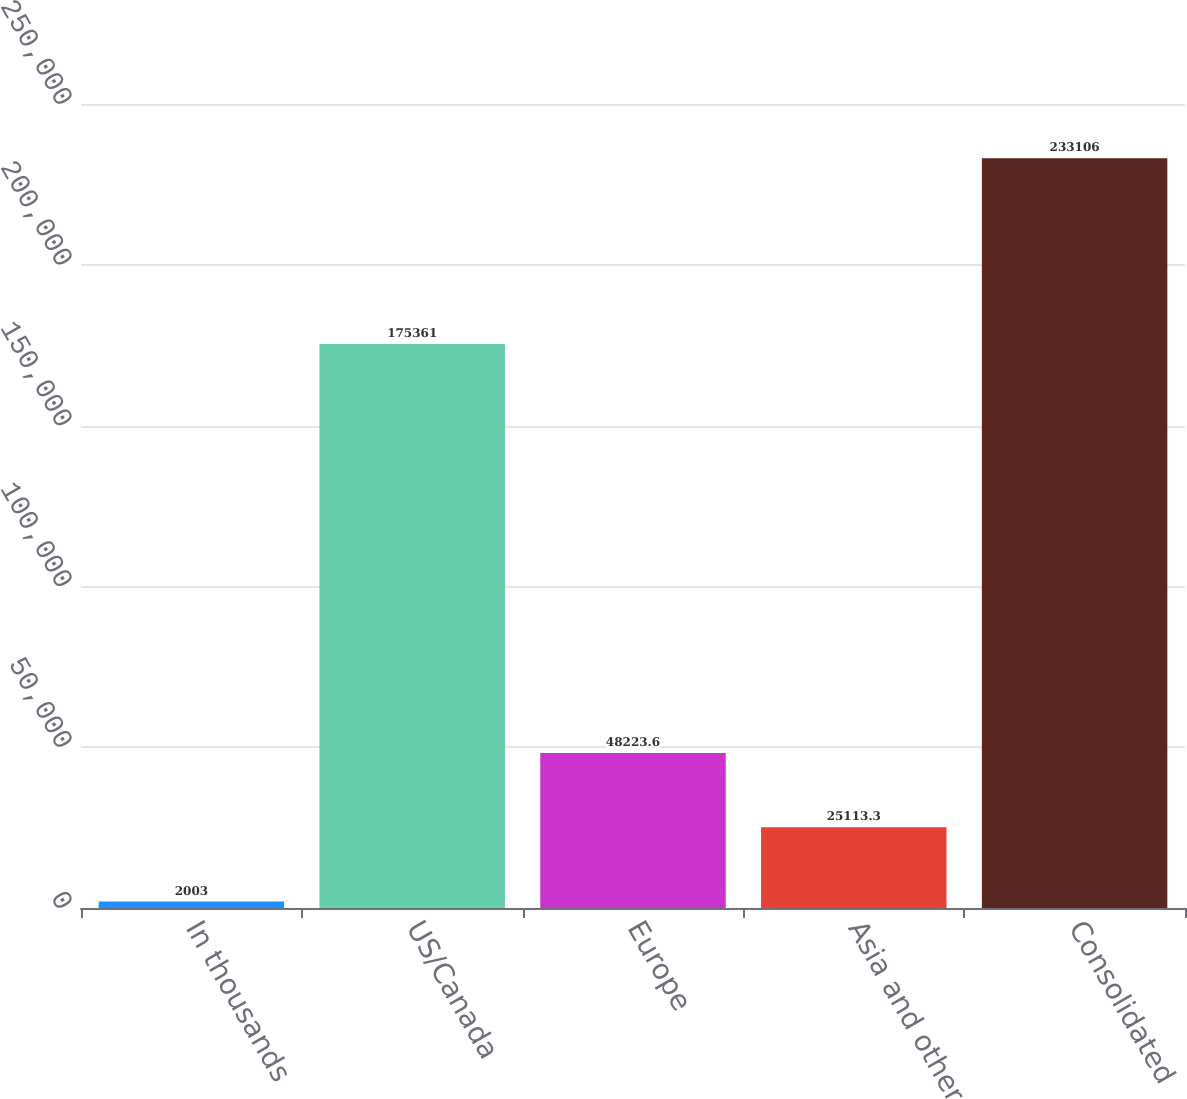Convert chart to OTSL. <chart><loc_0><loc_0><loc_500><loc_500><bar_chart><fcel>In thousands<fcel>US/Canada<fcel>Europe<fcel>Asia and other<fcel>Consolidated<nl><fcel>2003<fcel>175361<fcel>48223.6<fcel>25113.3<fcel>233106<nl></chart> 